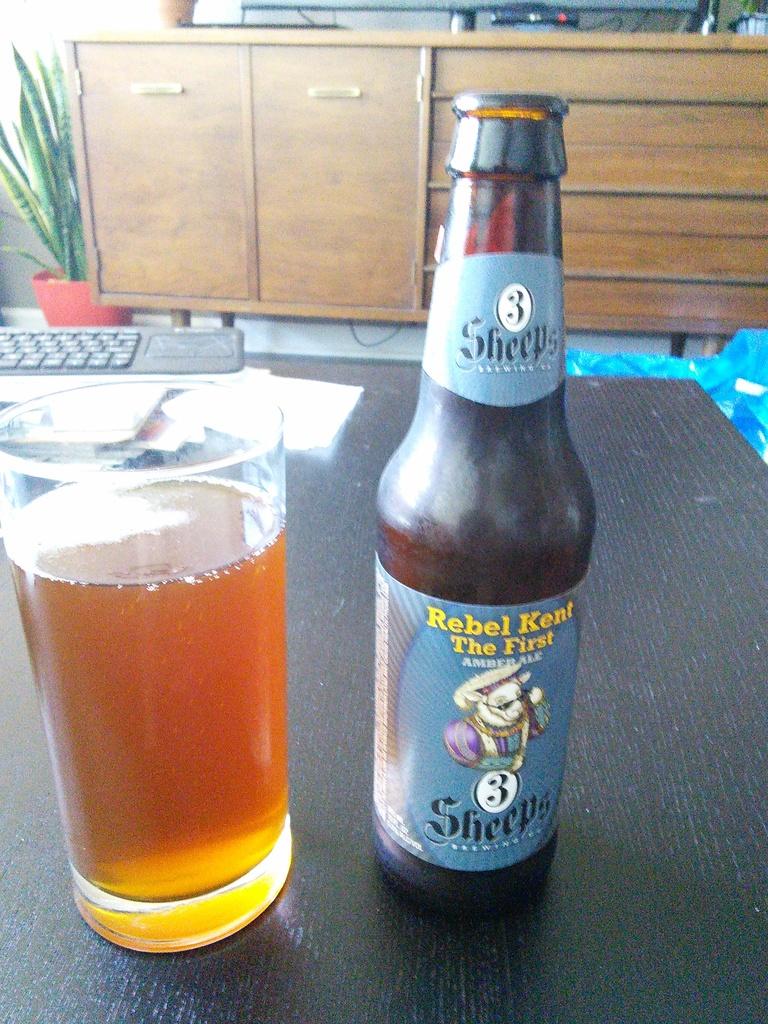What is the name of the beer?
Your answer should be very brief. Rebel kent the first. 